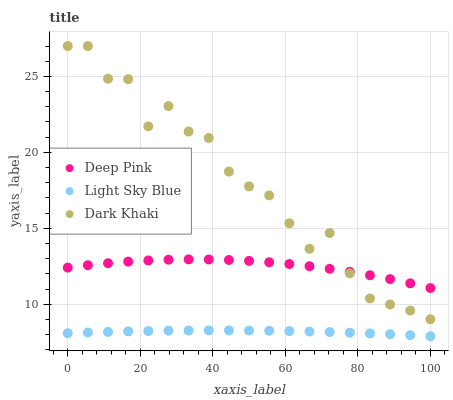Does Light Sky Blue have the minimum area under the curve?
Answer yes or no. Yes. Does Dark Khaki have the maximum area under the curve?
Answer yes or no. Yes. Does Deep Pink have the minimum area under the curve?
Answer yes or no. No. Does Deep Pink have the maximum area under the curve?
Answer yes or no. No. Is Light Sky Blue the smoothest?
Answer yes or no. Yes. Is Dark Khaki the roughest?
Answer yes or no. Yes. Is Deep Pink the smoothest?
Answer yes or no. No. Is Deep Pink the roughest?
Answer yes or no. No. Does Light Sky Blue have the lowest value?
Answer yes or no. Yes. Does Deep Pink have the lowest value?
Answer yes or no. No. Does Dark Khaki have the highest value?
Answer yes or no. Yes. Does Deep Pink have the highest value?
Answer yes or no. No. Is Light Sky Blue less than Dark Khaki?
Answer yes or no. Yes. Is Dark Khaki greater than Light Sky Blue?
Answer yes or no. Yes. Does Dark Khaki intersect Deep Pink?
Answer yes or no. Yes. Is Dark Khaki less than Deep Pink?
Answer yes or no. No. Is Dark Khaki greater than Deep Pink?
Answer yes or no. No. Does Light Sky Blue intersect Dark Khaki?
Answer yes or no. No. 